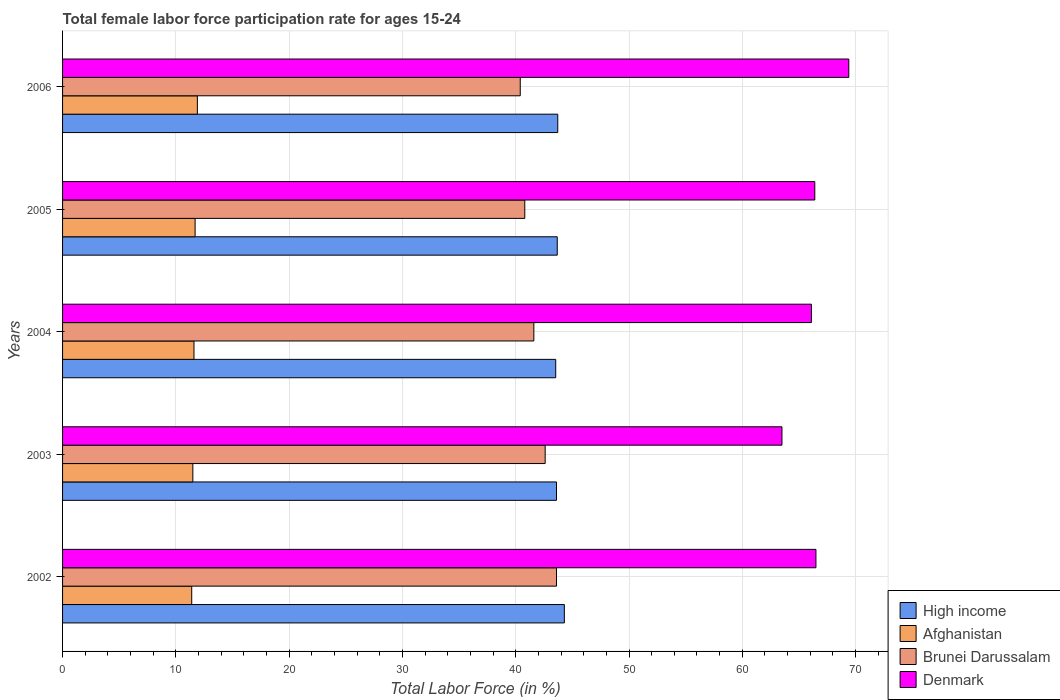How many groups of bars are there?
Provide a short and direct response. 5. How many bars are there on the 4th tick from the bottom?
Keep it short and to the point. 4. What is the female labor force participation rate in High income in 2005?
Your answer should be compact. 43.67. Across all years, what is the maximum female labor force participation rate in Afghanistan?
Make the answer very short. 11.9. Across all years, what is the minimum female labor force participation rate in Afghanistan?
Your answer should be very brief. 11.4. In which year was the female labor force participation rate in Denmark minimum?
Provide a succinct answer. 2003. What is the total female labor force participation rate in Afghanistan in the graph?
Ensure brevity in your answer.  58.1. What is the difference between the female labor force participation rate in Denmark in 2003 and that in 2006?
Provide a short and direct response. -5.9. What is the difference between the female labor force participation rate in Brunei Darussalam in 2004 and the female labor force participation rate in High income in 2006?
Ensure brevity in your answer.  -2.11. What is the average female labor force participation rate in Brunei Darussalam per year?
Provide a succinct answer. 41.8. In the year 2004, what is the difference between the female labor force participation rate in Brunei Darussalam and female labor force participation rate in Afghanistan?
Your response must be concise. 30. In how many years, is the female labor force participation rate in Afghanistan greater than 34 %?
Keep it short and to the point. 0. What is the ratio of the female labor force participation rate in Afghanistan in 2005 to that in 2006?
Offer a very short reply. 0.98. Is the difference between the female labor force participation rate in Brunei Darussalam in 2003 and 2004 greater than the difference between the female labor force participation rate in Afghanistan in 2003 and 2004?
Offer a very short reply. Yes. What is the difference between the highest and the second highest female labor force participation rate in High income?
Make the answer very short. 0.58. What is the difference between the highest and the lowest female labor force participation rate in High income?
Your answer should be compact. 0.76. Is the sum of the female labor force participation rate in Denmark in 2002 and 2004 greater than the maximum female labor force participation rate in High income across all years?
Give a very brief answer. Yes. What does the 3rd bar from the bottom in 2004 represents?
Give a very brief answer. Brunei Darussalam. Is it the case that in every year, the sum of the female labor force participation rate in Brunei Darussalam and female labor force participation rate in Afghanistan is greater than the female labor force participation rate in High income?
Provide a short and direct response. Yes. Does the graph contain any zero values?
Your answer should be compact. No. What is the title of the graph?
Offer a very short reply. Total female labor force participation rate for ages 15-24. What is the Total Labor Force (in %) in High income in 2002?
Your answer should be compact. 44.29. What is the Total Labor Force (in %) in Afghanistan in 2002?
Provide a short and direct response. 11.4. What is the Total Labor Force (in %) in Brunei Darussalam in 2002?
Offer a very short reply. 43.6. What is the Total Labor Force (in %) of Denmark in 2002?
Give a very brief answer. 66.5. What is the Total Labor Force (in %) of High income in 2003?
Ensure brevity in your answer.  43.6. What is the Total Labor Force (in %) of Brunei Darussalam in 2003?
Give a very brief answer. 42.6. What is the Total Labor Force (in %) in Denmark in 2003?
Offer a terse response. 63.5. What is the Total Labor Force (in %) in High income in 2004?
Make the answer very short. 43.53. What is the Total Labor Force (in %) of Afghanistan in 2004?
Ensure brevity in your answer.  11.6. What is the Total Labor Force (in %) in Brunei Darussalam in 2004?
Ensure brevity in your answer.  41.6. What is the Total Labor Force (in %) of Denmark in 2004?
Provide a succinct answer. 66.1. What is the Total Labor Force (in %) of High income in 2005?
Offer a very short reply. 43.67. What is the Total Labor Force (in %) in Afghanistan in 2005?
Give a very brief answer. 11.7. What is the Total Labor Force (in %) in Brunei Darussalam in 2005?
Your response must be concise. 40.8. What is the Total Labor Force (in %) in Denmark in 2005?
Your answer should be very brief. 66.4. What is the Total Labor Force (in %) in High income in 2006?
Provide a short and direct response. 43.71. What is the Total Labor Force (in %) in Afghanistan in 2006?
Offer a terse response. 11.9. What is the Total Labor Force (in %) of Brunei Darussalam in 2006?
Offer a very short reply. 40.4. What is the Total Labor Force (in %) of Denmark in 2006?
Give a very brief answer. 69.4. Across all years, what is the maximum Total Labor Force (in %) in High income?
Provide a succinct answer. 44.29. Across all years, what is the maximum Total Labor Force (in %) of Afghanistan?
Offer a very short reply. 11.9. Across all years, what is the maximum Total Labor Force (in %) of Brunei Darussalam?
Offer a very short reply. 43.6. Across all years, what is the maximum Total Labor Force (in %) in Denmark?
Offer a very short reply. 69.4. Across all years, what is the minimum Total Labor Force (in %) of High income?
Your response must be concise. 43.53. Across all years, what is the minimum Total Labor Force (in %) of Afghanistan?
Keep it short and to the point. 11.4. Across all years, what is the minimum Total Labor Force (in %) in Brunei Darussalam?
Provide a succinct answer. 40.4. Across all years, what is the minimum Total Labor Force (in %) of Denmark?
Offer a terse response. 63.5. What is the total Total Labor Force (in %) in High income in the graph?
Provide a succinct answer. 218.8. What is the total Total Labor Force (in %) of Afghanistan in the graph?
Your response must be concise. 58.1. What is the total Total Labor Force (in %) in Brunei Darussalam in the graph?
Make the answer very short. 209. What is the total Total Labor Force (in %) of Denmark in the graph?
Give a very brief answer. 331.9. What is the difference between the Total Labor Force (in %) in High income in 2002 and that in 2003?
Ensure brevity in your answer.  0.69. What is the difference between the Total Labor Force (in %) in Brunei Darussalam in 2002 and that in 2003?
Your answer should be compact. 1. What is the difference between the Total Labor Force (in %) of High income in 2002 and that in 2004?
Provide a succinct answer. 0.76. What is the difference between the Total Labor Force (in %) of Afghanistan in 2002 and that in 2004?
Ensure brevity in your answer.  -0.2. What is the difference between the Total Labor Force (in %) of Denmark in 2002 and that in 2004?
Your answer should be very brief. 0.4. What is the difference between the Total Labor Force (in %) in High income in 2002 and that in 2005?
Offer a terse response. 0.63. What is the difference between the Total Labor Force (in %) of Afghanistan in 2002 and that in 2005?
Keep it short and to the point. -0.3. What is the difference between the Total Labor Force (in %) in Denmark in 2002 and that in 2005?
Offer a very short reply. 0.1. What is the difference between the Total Labor Force (in %) in High income in 2002 and that in 2006?
Provide a short and direct response. 0.58. What is the difference between the Total Labor Force (in %) in Afghanistan in 2002 and that in 2006?
Your answer should be very brief. -0.5. What is the difference between the Total Labor Force (in %) of Denmark in 2002 and that in 2006?
Make the answer very short. -2.9. What is the difference between the Total Labor Force (in %) of High income in 2003 and that in 2004?
Give a very brief answer. 0.07. What is the difference between the Total Labor Force (in %) of High income in 2003 and that in 2005?
Provide a short and direct response. -0.07. What is the difference between the Total Labor Force (in %) of Afghanistan in 2003 and that in 2005?
Your answer should be compact. -0.2. What is the difference between the Total Labor Force (in %) of Denmark in 2003 and that in 2005?
Your response must be concise. -2.9. What is the difference between the Total Labor Force (in %) in High income in 2003 and that in 2006?
Keep it short and to the point. -0.11. What is the difference between the Total Labor Force (in %) in Afghanistan in 2003 and that in 2006?
Make the answer very short. -0.4. What is the difference between the Total Labor Force (in %) of Denmark in 2003 and that in 2006?
Provide a short and direct response. -5.9. What is the difference between the Total Labor Force (in %) of High income in 2004 and that in 2005?
Provide a short and direct response. -0.13. What is the difference between the Total Labor Force (in %) of Afghanistan in 2004 and that in 2005?
Your answer should be very brief. -0.1. What is the difference between the Total Labor Force (in %) of Brunei Darussalam in 2004 and that in 2005?
Keep it short and to the point. 0.8. What is the difference between the Total Labor Force (in %) of High income in 2004 and that in 2006?
Your answer should be compact. -0.18. What is the difference between the Total Labor Force (in %) of Afghanistan in 2004 and that in 2006?
Your answer should be compact. -0.3. What is the difference between the Total Labor Force (in %) in High income in 2005 and that in 2006?
Your answer should be very brief. -0.05. What is the difference between the Total Labor Force (in %) of Afghanistan in 2005 and that in 2006?
Make the answer very short. -0.2. What is the difference between the Total Labor Force (in %) in High income in 2002 and the Total Labor Force (in %) in Afghanistan in 2003?
Ensure brevity in your answer.  32.79. What is the difference between the Total Labor Force (in %) of High income in 2002 and the Total Labor Force (in %) of Brunei Darussalam in 2003?
Provide a short and direct response. 1.69. What is the difference between the Total Labor Force (in %) of High income in 2002 and the Total Labor Force (in %) of Denmark in 2003?
Offer a very short reply. -19.21. What is the difference between the Total Labor Force (in %) in Afghanistan in 2002 and the Total Labor Force (in %) in Brunei Darussalam in 2003?
Your answer should be very brief. -31.2. What is the difference between the Total Labor Force (in %) in Afghanistan in 2002 and the Total Labor Force (in %) in Denmark in 2003?
Your answer should be very brief. -52.1. What is the difference between the Total Labor Force (in %) of Brunei Darussalam in 2002 and the Total Labor Force (in %) of Denmark in 2003?
Offer a terse response. -19.9. What is the difference between the Total Labor Force (in %) in High income in 2002 and the Total Labor Force (in %) in Afghanistan in 2004?
Provide a short and direct response. 32.69. What is the difference between the Total Labor Force (in %) in High income in 2002 and the Total Labor Force (in %) in Brunei Darussalam in 2004?
Keep it short and to the point. 2.69. What is the difference between the Total Labor Force (in %) in High income in 2002 and the Total Labor Force (in %) in Denmark in 2004?
Ensure brevity in your answer.  -21.81. What is the difference between the Total Labor Force (in %) in Afghanistan in 2002 and the Total Labor Force (in %) in Brunei Darussalam in 2004?
Give a very brief answer. -30.2. What is the difference between the Total Labor Force (in %) in Afghanistan in 2002 and the Total Labor Force (in %) in Denmark in 2004?
Give a very brief answer. -54.7. What is the difference between the Total Labor Force (in %) in Brunei Darussalam in 2002 and the Total Labor Force (in %) in Denmark in 2004?
Give a very brief answer. -22.5. What is the difference between the Total Labor Force (in %) of High income in 2002 and the Total Labor Force (in %) of Afghanistan in 2005?
Offer a very short reply. 32.59. What is the difference between the Total Labor Force (in %) in High income in 2002 and the Total Labor Force (in %) in Brunei Darussalam in 2005?
Offer a very short reply. 3.49. What is the difference between the Total Labor Force (in %) in High income in 2002 and the Total Labor Force (in %) in Denmark in 2005?
Offer a very short reply. -22.11. What is the difference between the Total Labor Force (in %) in Afghanistan in 2002 and the Total Labor Force (in %) in Brunei Darussalam in 2005?
Your answer should be very brief. -29.4. What is the difference between the Total Labor Force (in %) of Afghanistan in 2002 and the Total Labor Force (in %) of Denmark in 2005?
Your answer should be very brief. -55. What is the difference between the Total Labor Force (in %) in Brunei Darussalam in 2002 and the Total Labor Force (in %) in Denmark in 2005?
Make the answer very short. -22.8. What is the difference between the Total Labor Force (in %) of High income in 2002 and the Total Labor Force (in %) of Afghanistan in 2006?
Your answer should be compact. 32.39. What is the difference between the Total Labor Force (in %) in High income in 2002 and the Total Labor Force (in %) in Brunei Darussalam in 2006?
Provide a short and direct response. 3.89. What is the difference between the Total Labor Force (in %) in High income in 2002 and the Total Labor Force (in %) in Denmark in 2006?
Ensure brevity in your answer.  -25.11. What is the difference between the Total Labor Force (in %) of Afghanistan in 2002 and the Total Labor Force (in %) of Brunei Darussalam in 2006?
Give a very brief answer. -29. What is the difference between the Total Labor Force (in %) in Afghanistan in 2002 and the Total Labor Force (in %) in Denmark in 2006?
Offer a very short reply. -58. What is the difference between the Total Labor Force (in %) of Brunei Darussalam in 2002 and the Total Labor Force (in %) of Denmark in 2006?
Provide a short and direct response. -25.8. What is the difference between the Total Labor Force (in %) of High income in 2003 and the Total Labor Force (in %) of Afghanistan in 2004?
Ensure brevity in your answer.  32. What is the difference between the Total Labor Force (in %) in High income in 2003 and the Total Labor Force (in %) in Brunei Darussalam in 2004?
Provide a short and direct response. 2. What is the difference between the Total Labor Force (in %) of High income in 2003 and the Total Labor Force (in %) of Denmark in 2004?
Ensure brevity in your answer.  -22.5. What is the difference between the Total Labor Force (in %) in Afghanistan in 2003 and the Total Labor Force (in %) in Brunei Darussalam in 2004?
Make the answer very short. -30.1. What is the difference between the Total Labor Force (in %) of Afghanistan in 2003 and the Total Labor Force (in %) of Denmark in 2004?
Provide a succinct answer. -54.6. What is the difference between the Total Labor Force (in %) in Brunei Darussalam in 2003 and the Total Labor Force (in %) in Denmark in 2004?
Keep it short and to the point. -23.5. What is the difference between the Total Labor Force (in %) in High income in 2003 and the Total Labor Force (in %) in Afghanistan in 2005?
Your response must be concise. 31.9. What is the difference between the Total Labor Force (in %) of High income in 2003 and the Total Labor Force (in %) of Brunei Darussalam in 2005?
Ensure brevity in your answer.  2.8. What is the difference between the Total Labor Force (in %) of High income in 2003 and the Total Labor Force (in %) of Denmark in 2005?
Offer a very short reply. -22.8. What is the difference between the Total Labor Force (in %) in Afghanistan in 2003 and the Total Labor Force (in %) in Brunei Darussalam in 2005?
Offer a terse response. -29.3. What is the difference between the Total Labor Force (in %) of Afghanistan in 2003 and the Total Labor Force (in %) of Denmark in 2005?
Your answer should be compact. -54.9. What is the difference between the Total Labor Force (in %) of Brunei Darussalam in 2003 and the Total Labor Force (in %) of Denmark in 2005?
Ensure brevity in your answer.  -23.8. What is the difference between the Total Labor Force (in %) of High income in 2003 and the Total Labor Force (in %) of Afghanistan in 2006?
Your answer should be compact. 31.7. What is the difference between the Total Labor Force (in %) in High income in 2003 and the Total Labor Force (in %) in Brunei Darussalam in 2006?
Offer a terse response. 3.2. What is the difference between the Total Labor Force (in %) in High income in 2003 and the Total Labor Force (in %) in Denmark in 2006?
Ensure brevity in your answer.  -25.8. What is the difference between the Total Labor Force (in %) in Afghanistan in 2003 and the Total Labor Force (in %) in Brunei Darussalam in 2006?
Offer a very short reply. -28.9. What is the difference between the Total Labor Force (in %) of Afghanistan in 2003 and the Total Labor Force (in %) of Denmark in 2006?
Make the answer very short. -57.9. What is the difference between the Total Labor Force (in %) of Brunei Darussalam in 2003 and the Total Labor Force (in %) of Denmark in 2006?
Make the answer very short. -26.8. What is the difference between the Total Labor Force (in %) of High income in 2004 and the Total Labor Force (in %) of Afghanistan in 2005?
Offer a very short reply. 31.83. What is the difference between the Total Labor Force (in %) of High income in 2004 and the Total Labor Force (in %) of Brunei Darussalam in 2005?
Give a very brief answer. 2.73. What is the difference between the Total Labor Force (in %) in High income in 2004 and the Total Labor Force (in %) in Denmark in 2005?
Give a very brief answer. -22.87. What is the difference between the Total Labor Force (in %) of Afghanistan in 2004 and the Total Labor Force (in %) of Brunei Darussalam in 2005?
Your response must be concise. -29.2. What is the difference between the Total Labor Force (in %) of Afghanistan in 2004 and the Total Labor Force (in %) of Denmark in 2005?
Provide a succinct answer. -54.8. What is the difference between the Total Labor Force (in %) in Brunei Darussalam in 2004 and the Total Labor Force (in %) in Denmark in 2005?
Your response must be concise. -24.8. What is the difference between the Total Labor Force (in %) in High income in 2004 and the Total Labor Force (in %) in Afghanistan in 2006?
Provide a short and direct response. 31.63. What is the difference between the Total Labor Force (in %) of High income in 2004 and the Total Labor Force (in %) of Brunei Darussalam in 2006?
Ensure brevity in your answer.  3.13. What is the difference between the Total Labor Force (in %) of High income in 2004 and the Total Labor Force (in %) of Denmark in 2006?
Offer a terse response. -25.87. What is the difference between the Total Labor Force (in %) in Afghanistan in 2004 and the Total Labor Force (in %) in Brunei Darussalam in 2006?
Provide a succinct answer. -28.8. What is the difference between the Total Labor Force (in %) of Afghanistan in 2004 and the Total Labor Force (in %) of Denmark in 2006?
Your answer should be compact. -57.8. What is the difference between the Total Labor Force (in %) in Brunei Darussalam in 2004 and the Total Labor Force (in %) in Denmark in 2006?
Ensure brevity in your answer.  -27.8. What is the difference between the Total Labor Force (in %) of High income in 2005 and the Total Labor Force (in %) of Afghanistan in 2006?
Offer a terse response. 31.77. What is the difference between the Total Labor Force (in %) of High income in 2005 and the Total Labor Force (in %) of Brunei Darussalam in 2006?
Provide a short and direct response. 3.27. What is the difference between the Total Labor Force (in %) of High income in 2005 and the Total Labor Force (in %) of Denmark in 2006?
Your answer should be compact. -25.73. What is the difference between the Total Labor Force (in %) of Afghanistan in 2005 and the Total Labor Force (in %) of Brunei Darussalam in 2006?
Offer a terse response. -28.7. What is the difference between the Total Labor Force (in %) in Afghanistan in 2005 and the Total Labor Force (in %) in Denmark in 2006?
Keep it short and to the point. -57.7. What is the difference between the Total Labor Force (in %) in Brunei Darussalam in 2005 and the Total Labor Force (in %) in Denmark in 2006?
Your answer should be compact. -28.6. What is the average Total Labor Force (in %) in High income per year?
Make the answer very short. 43.76. What is the average Total Labor Force (in %) of Afghanistan per year?
Offer a terse response. 11.62. What is the average Total Labor Force (in %) in Brunei Darussalam per year?
Your answer should be very brief. 41.8. What is the average Total Labor Force (in %) of Denmark per year?
Your response must be concise. 66.38. In the year 2002, what is the difference between the Total Labor Force (in %) in High income and Total Labor Force (in %) in Afghanistan?
Your answer should be very brief. 32.89. In the year 2002, what is the difference between the Total Labor Force (in %) of High income and Total Labor Force (in %) of Brunei Darussalam?
Keep it short and to the point. 0.69. In the year 2002, what is the difference between the Total Labor Force (in %) of High income and Total Labor Force (in %) of Denmark?
Offer a very short reply. -22.21. In the year 2002, what is the difference between the Total Labor Force (in %) in Afghanistan and Total Labor Force (in %) in Brunei Darussalam?
Your answer should be compact. -32.2. In the year 2002, what is the difference between the Total Labor Force (in %) of Afghanistan and Total Labor Force (in %) of Denmark?
Your response must be concise. -55.1. In the year 2002, what is the difference between the Total Labor Force (in %) of Brunei Darussalam and Total Labor Force (in %) of Denmark?
Provide a short and direct response. -22.9. In the year 2003, what is the difference between the Total Labor Force (in %) of High income and Total Labor Force (in %) of Afghanistan?
Make the answer very short. 32.1. In the year 2003, what is the difference between the Total Labor Force (in %) in High income and Total Labor Force (in %) in Brunei Darussalam?
Make the answer very short. 1. In the year 2003, what is the difference between the Total Labor Force (in %) of High income and Total Labor Force (in %) of Denmark?
Offer a very short reply. -19.9. In the year 2003, what is the difference between the Total Labor Force (in %) in Afghanistan and Total Labor Force (in %) in Brunei Darussalam?
Your answer should be very brief. -31.1. In the year 2003, what is the difference between the Total Labor Force (in %) in Afghanistan and Total Labor Force (in %) in Denmark?
Give a very brief answer. -52. In the year 2003, what is the difference between the Total Labor Force (in %) in Brunei Darussalam and Total Labor Force (in %) in Denmark?
Ensure brevity in your answer.  -20.9. In the year 2004, what is the difference between the Total Labor Force (in %) of High income and Total Labor Force (in %) of Afghanistan?
Provide a short and direct response. 31.93. In the year 2004, what is the difference between the Total Labor Force (in %) of High income and Total Labor Force (in %) of Brunei Darussalam?
Offer a terse response. 1.93. In the year 2004, what is the difference between the Total Labor Force (in %) of High income and Total Labor Force (in %) of Denmark?
Provide a short and direct response. -22.57. In the year 2004, what is the difference between the Total Labor Force (in %) in Afghanistan and Total Labor Force (in %) in Denmark?
Make the answer very short. -54.5. In the year 2004, what is the difference between the Total Labor Force (in %) of Brunei Darussalam and Total Labor Force (in %) of Denmark?
Offer a very short reply. -24.5. In the year 2005, what is the difference between the Total Labor Force (in %) of High income and Total Labor Force (in %) of Afghanistan?
Ensure brevity in your answer.  31.97. In the year 2005, what is the difference between the Total Labor Force (in %) in High income and Total Labor Force (in %) in Brunei Darussalam?
Provide a succinct answer. 2.87. In the year 2005, what is the difference between the Total Labor Force (in %) of High income and Total Labor Force (in %) of Denmark?
Your response must be concise. -22.73. In the year 2005, what is the difference between the Total Labor Force (in %) of Afghanistan and Total Labor Force (in %) of Brunei Darussalam?
Offer a very short reply. -29.1. In the year 2005, what is the difference between the Total Labor Force (in %) in Afghanistan and Total Labor Force (in %) in Denmark?
Offer a very short reply. -54.7. In the year 2005, what is the difference between the Total Labor Force (in %) of Brunei Darussalam and Total Labor Force (in %) of Denmark?
Your response must be concise. -25.6. In the year 2006, what is the difference between the Total Labor Force (in %) in High income and Total Labor Force (in %) in Afghanistan?
Give a very brief answer. 31.81. In the year 2006, what is the difference between the Total Labor Force (in %) in High income and Total Labor Force (in %) in Brunei Darussalam?
Provide a short and direct response. 3.31. In the year 2006, what is the difference between the Total Labor Force (in %) of High income and Total Labor Force (in %) of Denmark?
Provide a short and direct response. -25.69. In the year 2006, what is the difference between the Total Labor Force (in %) of Afghanistan and Total Labor Force (in %) of Brunei Darussalam?
Offer a very short reply. -28.5. In the year 2006, what is the difference between the Total Labor Force (in %) of Afghanistan and Total Labor Force (in %) of Denmark?
Offer a terse response. -57.5. In the year 2006, what is the difference between the Total Labor Force (in %) of Brunei Darussalam and Total Labor Force (in %) of Denmark?
Offer a very short reply. -29. What is the ratio of the Total Labor Force (in %) of High income in 2002 to that in 2003?
Make the answer very short. 1.02. What is the ratio of the Total Labor Force (in %) in Afghanistan in 2002 to that in 2003?
Your response must be concise. 0.99. What is the ratio of the Total Labor Force (in %) of Brunei Darussalam in 2002 to that in 2003?
Provide a short and direct response. 1.02. What is the ratio of the Total Labor Force (in %) of Denmark in 2002 to that in 2003?
Offer a very short reply. 1.05. What is the ratio of the Total Labor Force (in %) in High income in 2002 to that in 2004?
Offer a terse response. 1.02. What is the ratio of the Total Labor Force (in %) in Afghanistan in 2002 to that in 2004?
Ensure brevity in your answer.  0.98. What is the ratio of the Total Labor Force (in %) in Brunei Darussalam in 2002 to that in 2004?
Ensure brevity in your answer.  1.05. What is the ratio of the Total Labor Force (in %) in Denmark in 2002 to that in 2004?
Give a very brief answer. 1.01. What is the ratio of the Total Labor Force (in %) in High income in 2002 to that in 2005?
Your answer should be very brief. 1.01. What is the ratio of the Total Labor Force (in %) in Afghanistan in 2002 to that in 2005?
Your response must be concise. 0.97. What is the ratio of the Total Labor Force (in %) of Brunei Darussalam in 2002 to that in 2005?
Give a very brief answer. 1.07. What is the ratio of the Total Labor Force (in %) in High income in 2002 to that in 2006?
Your answer should be compact. 1.01. What is the ratio of the Total Labor Force (in %) of Afghanistan in 2002 to that in 2006?
Ensure brevity in your answer.  0.96. What is the ratio of the Total Labor Force (in %) of Brunei Darussalam in 2002 to that in 2006?
Offer a terse response. 1.08. What is the ratio of the Total Labor Force (in %) in Denmark in 2002 to that in 2006?
Offer a very short reply. 0.96. What is the ratio of the Total Labor Force (in %) of High income in 2003 to that in 2004?
Give a very brief answer. 1. What is the ratio of the Total Labor Force (in %) of Brunei Darussalam in 2003 to that in 2004?
Your answer should be compact. 1.02. What is the ratio of the Total Labor Force (in %) of Denmark in 2003 to that in 2004?
Ensure brevity in your answer.  0.96. What is the ratio of the Total Labor Force (in %) of Afghanistan in 2003 to that in 2005?
Ensure brevity in your answer.  0.98. What is the ratio of the Total Labor Force (in %) in Brunei Darussalam in 2003 to that in 2005?
Make the answer very short. 1.04. What is the ratio of the Total Labor Force (in %) of Denmark in 2003 to that in 2005?
Give a very brief answer. 0.96. What is the ratio of the Total Labor Force (in %) in Afghanistan in 2003 to that in 2006?
Offer a terse response. 0.97. What is the ratio of the Total Labor Force (in %) of Brunei Darussalam in 2003 to that in 2006?
Your answer should be very brief. 1.05. What is the ratio of the Total Labor Force (in %) in Denmark in 2003 to that in 2006?
Offer a terse response. 0.92. What is the ratio of the Total Labor Force (in %) in High income in 2004 to that in 2005?
Your answer should be compact. 1. What is the ratio of the Total Labor Force (in %) of Afghanistan in 2004 to that in 2005?
Provide a short and direct response. 0.99. What is the ratio of the Total Labor Force (in %) in Brunei Darussalam in 2004 to that in 2005?
Offer a very short reply. 1.02. What is the ratio of the Total Labor Force (in %) of Denmark in 2004 to that in 2005?
Keep it short and to the point. 1. What is the ratio of the Total Labor Force (in %) in Afghanistan in 2004 to that in 2006?
Keep it short and to the point. 0.97. What is the ratio of the Total Labor Force (in %) in Brunei Darussalam in 2004 to that in 2006?
Give a very brief answer. 1.03. What is the ratio of the Total Labor Force (in %) of Denmark in 2004 to that in 2006?
Provide a succinct answer. 0.95. What is the ratio of the Total Labor Force (in %) in High income in 2005 to that in 2006?
Make the answer very short. 1. What is the ratio of the Total Labor Force (in %) in Afghanistan in 2005 to that in 2006?
Keep it short and to the point. 0.98. What is the ratio of the Total Labor Force (in %) in Brunei Darussalam in 2005 to that in 2006?
Make the answer very short. 1.01. What is the ratio of the Total Labor Force (in %) of Denmark in 2005 to that in 2006?
Your answer should be very brief. 0.96. What is the difference between the highest and the second highest Total Labor Force (in %) in High income?
Give a very brief answer. 0.58. What is the difference between the highest and the lowest Total Labor Force (in %) of High income?
Provide a short and direct response. 0.76. What is the difference between the highest and the lowest Total Labor Force (in %) of Afghanistan?
Your answer should be very brief. 0.5. 